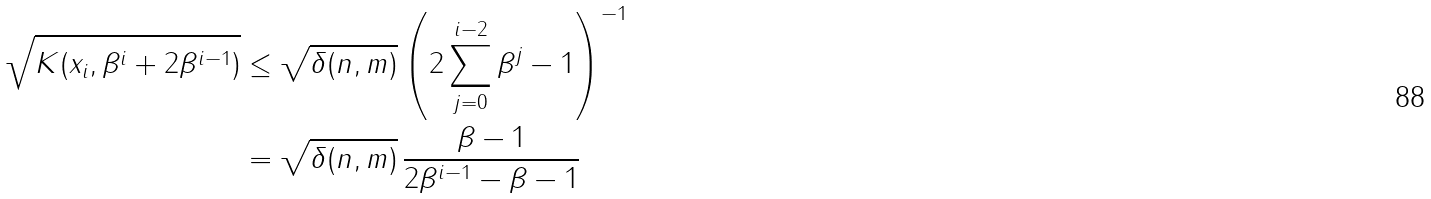<formula> <loc_0><loc_0><loc_500><loc_500>\sqrt { K ( x _ { i } , \beta ^ { i } + 2 \beta ^ { i - 1 } ) } & \leq \sqrt { \delta ( n , m ) } \left ( 2 \sum ^ { i - 2 } _ { j = 0 } \beta ^ { j } - 1 \right ) ^ { - 1 } \\ & = \sqrt { \delta ( n , m ) } \, \frac { \beta - 1 } { 2 \beta ^ { i - 1 } - \beta - 1 }</formula> 